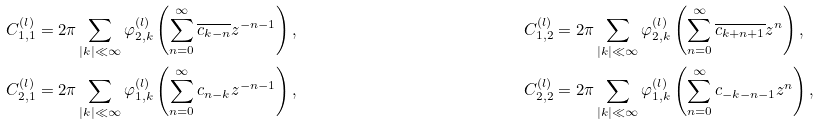<formula> <loc_0><loc_0><loc_500><loc_500>C _ { 1 , 1 } ^ { ( l ) } & = 2 \pi \sum _ { | k | \ll \infty } \varphi ^ { ( l ) } _ { 2 , k } \left ( \sum _ { n = 0 } ^ { \infty } \overline { c _ { k - n } } z ^ { - n - 1 } \right ) , & C _ { 1 , 2 } ^ { ( l ) } & = 2 \pi \sum _ { | k | \ll \infty } \varphi ^ { ( l ) } _ { 2 , k } \left ( \sum _ { n = 0 } ^ { \infty } \overline { c _ { k + n + 1 } } z ^ { n } \right ) , \\ C _ { 2 , 1 } ^ { ( l ) } & = 2 \pi \sum _ { | k | \ll \infty } \varphi ^ { ( l ) } _ { 1 , k } \left ( \sum _ { n = 0 } ^ { \infty } c _ { n - k } z ^ { - n - 1 } \right ) , & C _ { 2 , 2 } ^ { ( l ) } & = 2 \pi \sum _ { | k | \ll \infty } \varphi ^ { ( l ) } _ { 1 , k } \left ( \sum _ { n = 0 } ^ { \infty } c _ { - k - n - 1 } z ^ { n } \right ) ,</formula> 